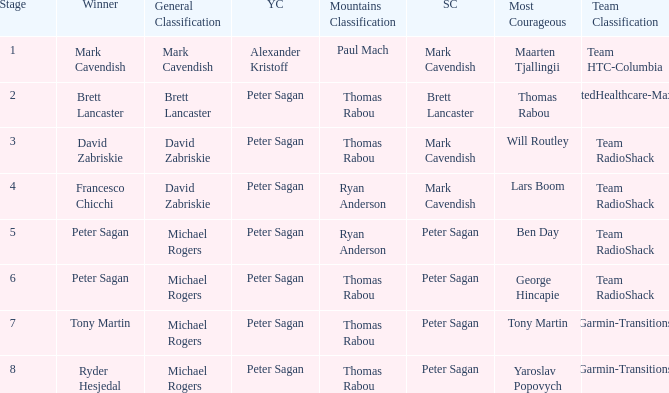Give me the full table as a dictionary. {'header': ['Stage', 'Winner', 'General Classification', 'YC', 'Mountains Classification', 'SC', 'Most Courageous', 'Team Classification'], 'rows': [['1', 'Mark Cavendish', 'Mark Cavendish', 'Alexander Kristoff', 'Paul Mach', 'Mark Cavendish', 'Maarten Tjallingii', 'Team HTC-Columbia'], ['2', 'Brett Lancaster', 'Brett Lancaster', 'Peter Sagan', 'Thomas Rabou', 'Brett Lancaster', 'Thomas Rabou', 'UnitedHealthcare-Maxxis'], ['3', 'David Zabriskie', 'David Zabriskie', 'Peter Sagan', 'Thomas Rabou', 'Mark Cavendish', 'Will Routley', 'Team RadioShack'], ['4', 'Francesco Chicchi', 'David Zabriskie', 'Peter Sagan', 'Ryan Anderson', 'Mark Cavendish', 'Lars Boom', 'Team RadioShack'], ['5', 'Peter Sagan', 'Michael Rogers', 'Peter Sagan', 'Ryan Anderson', 'Peter Sagan', 'Ben Day', 'Team RadioShack'], ['6', 'Peter Sagan', 'Michael Rogers', 'Peter Sagan', 'Thomas Rabou', 'Peter Sagan', 'George Hincapie', 'Team RadioShack'], ['7', 'Tony Martin', 'Michael Rogers', 'Peter Sagan', 'Thomas Rabou', 'Peter Sagan', 'Tony Martin', 'Garmin-Transitions'], ['8', 'Ryder Hesjedal', 'Michael Rogers', 'Peter Sagan', 'Thomas Rabou', 'Peter Sagan', 'Yaroslav Popovych', 'Garmin-Transitions']]} When Yaroslav Popovych won most corageous, who won the mountains classification? Thomas Rabou. 